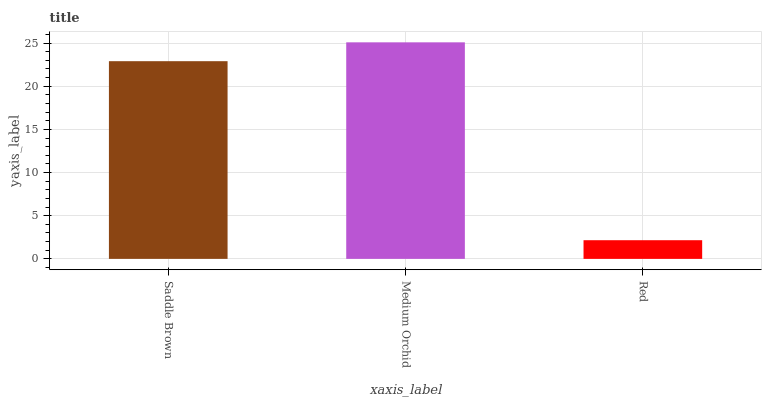Is Red the minimum?
Answer yes or no. Yes. Is Medium Orchid the maximum?
Answer yes or no. Yes. Is Medium Orchid the minimum?
Answer yes or no. No. Is Red the maximum?
Answer yes or no. No. Is Medium Orchid greater than Red?
Answer yes or no. Yes. Is Red less than Medium Orchid?
Answer yes or no. Yes. Is Red greater than Medium Orchid?
Answer yes or no. No. Is Medium Orchid less than Red?
Answer yes or no. No. Is Saddle Brown the high median?
Answer yes or no. Yes. Is Saddle Brown the low median?
Answer yes or no. Yes. Is Medium Orchid the high median?
Answer yes or no. No. Is Red the low median?
Answer yes or no. No. 